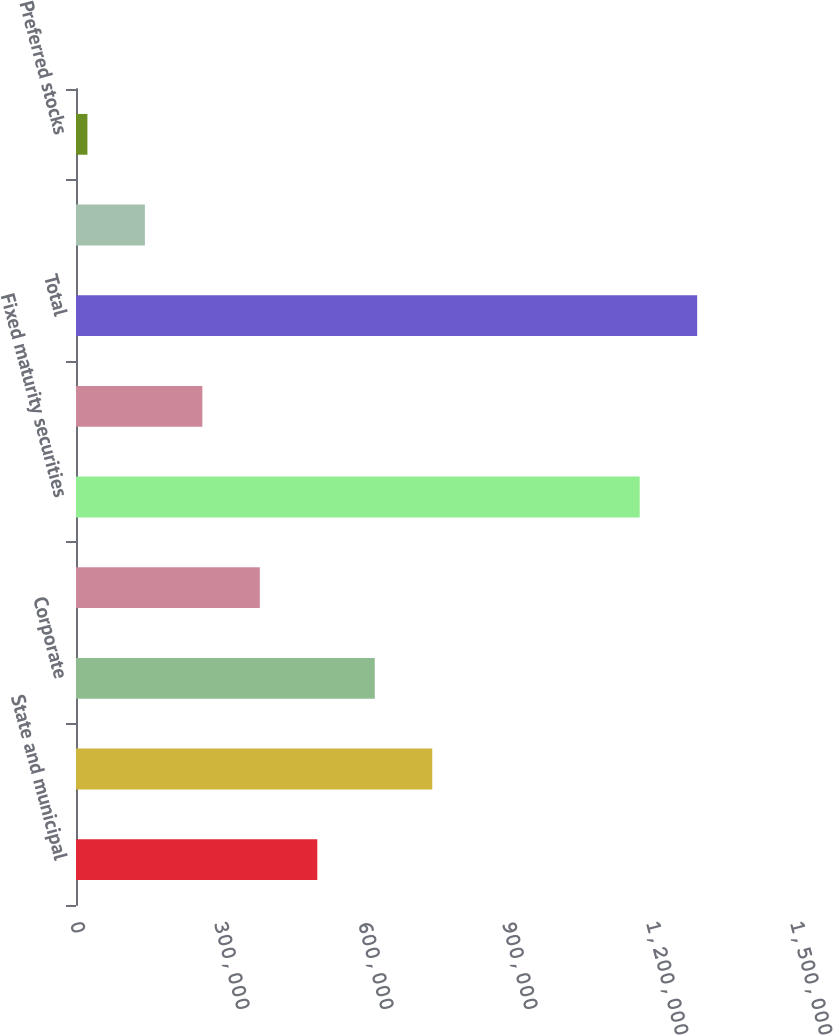<chart> <loc_0><loc_0><loc_500><loc_500><bar_chart><fcel>State and municipal<fcel>Mortgage-backed securities<fcel>Corporate<fcel>Foreign<fcel>Fixed maturity securities<fcel>Equity securities available<fcel>Total<fcel>US government and government<fcel>Preferred stocks<nl><fcel>502711<fcel>742176<fcel>622444<fcel>382979<fcel>1.17438e+06<fcel>263247<fcel>1.29411e+06<fcel>143514<fcel>23782<nl></chart> 